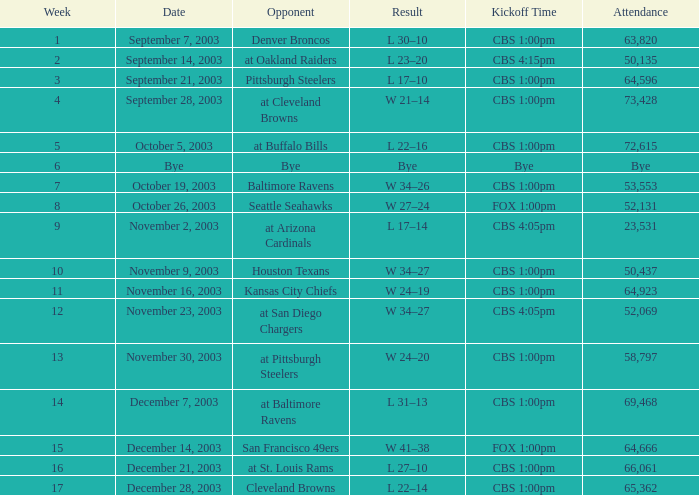What is the average number of weeks that the opponent was the Denver Broncos? 1.0. 